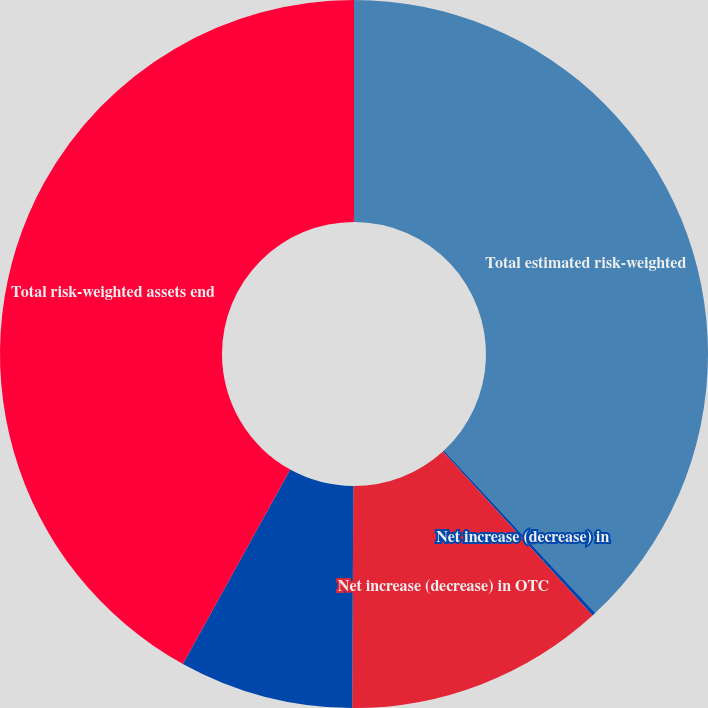Convert chart. <chart><loc_0><loc_0><loc_500><loc_500><pie_chart><fcel>Total estimated risk-weighted<fcel>Net increase (decrease) in<fcel>Net increase (decrease) in OTC<fcel>Net increase (decrease) in all<fcel>Total risk-weighted assets end<nl><fcel>38.07%<fcel>0.16%<fcel>11.85%<fcel>7.95%<fcel>41.97%<nl></chart> 